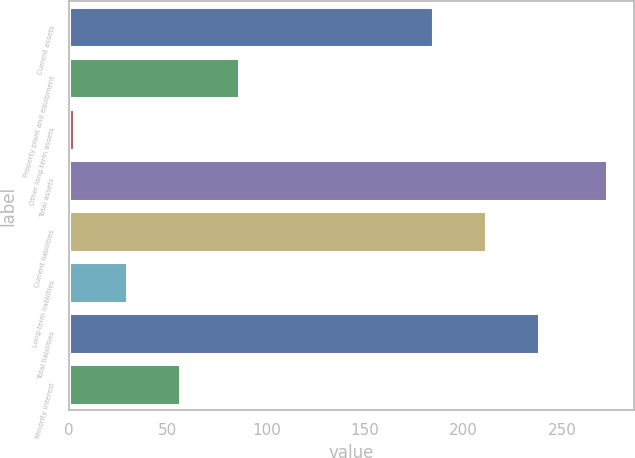<chart> <loc_0><loc_0><loc_500><loc_500><bar_chart><fcel>Current assets<fcel>Property plant and equipment<fcel>Other long-term assets<fcel>Total assets<fcel>Current liabilities<fcel>Long-term liabilities<fcel>Total liabilities<fcel>Minority interest<nl><fcel>184.3<fcel>85.9<fcel>2.3<fcel>272.5<fcel>211.32<fcel>29.32<fcel>238.34<fcel>56.34<nl></chart> 